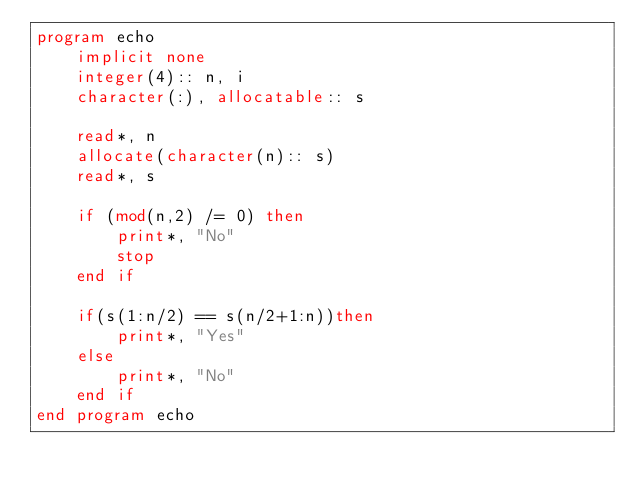Convert code to text. <code><loc_0><loc_0><loc_500><loc_500><_FORTRAN_>program echo
    implicit none
    integer(4):: n, i
    character(:), allocatable:: s

    read*, n
    allocate(character(n):: s)
    read*, s

    if (mod(n,2) /= 0) then
        print*, "No"
        stop
    end if

    if(s(1:n/2) == s(n/2+1:n))then
        print*, "Yes"
    else
        print*, "No"
    end if
end program echo</code> 